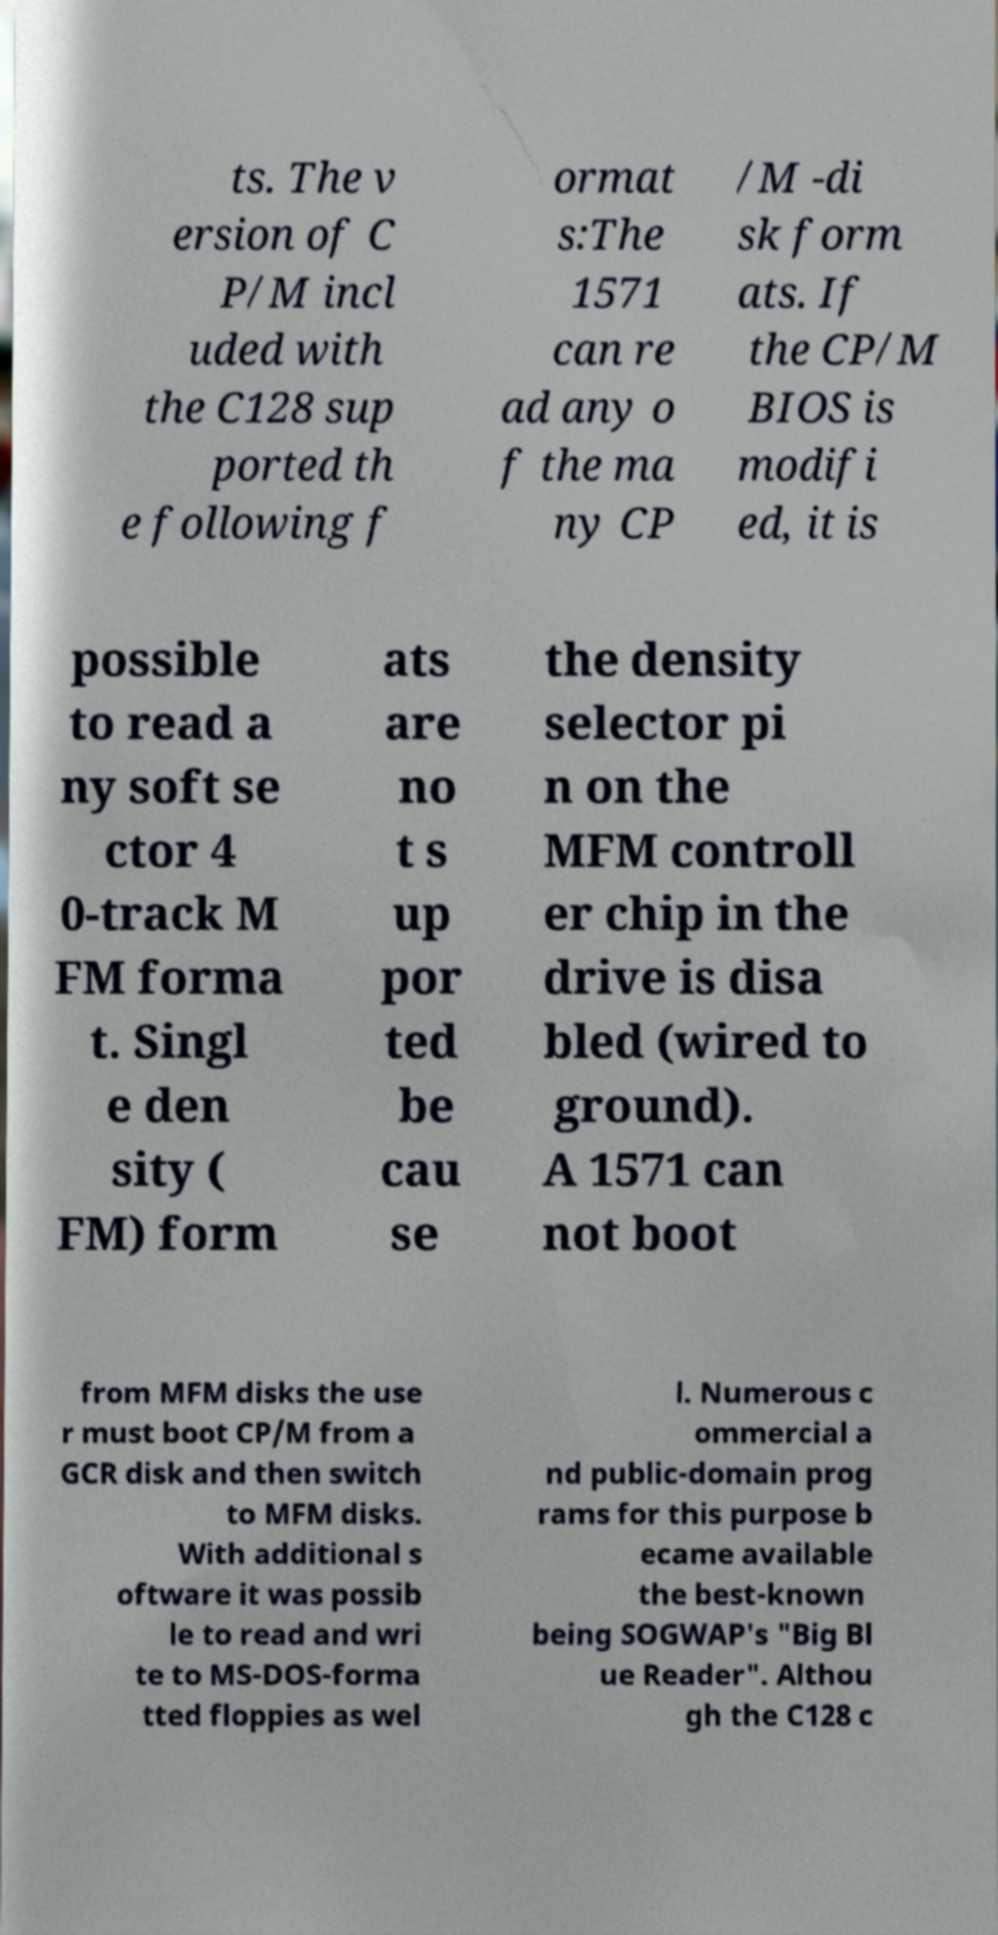For documentation purposes, I need the text within this image transcribed. Could you provide that? ts. The v ersion of C P/M incl uded with the C128 sup ported th e following f ormat s:The 1571 can re ad any o f the ma ny CP /M -di sk form ats. If the CP/M BIOS is modifi ed, it is possible to read a ny soft se ctor 4 0-track M FM forma t. Singl e den sity ( FM) form ats are no t s up por ted be cau se the density selector pi n on the MFM controll er chip in the drive is disa bled (wired to ground). A 1571 can not boot from MFM disks the use r must boot CP/M from a GCR disk and then switch to MFM disks. With additional s oftware it was possib le to read and wri te to MS-DOS-forma tted floppies as wel l. Numerous c ommercial a nd public-domain prog rams for this purpose b ecame available the best-known being SOGWAP's "Big Bl ue Reader". Althou gh the C128 c 